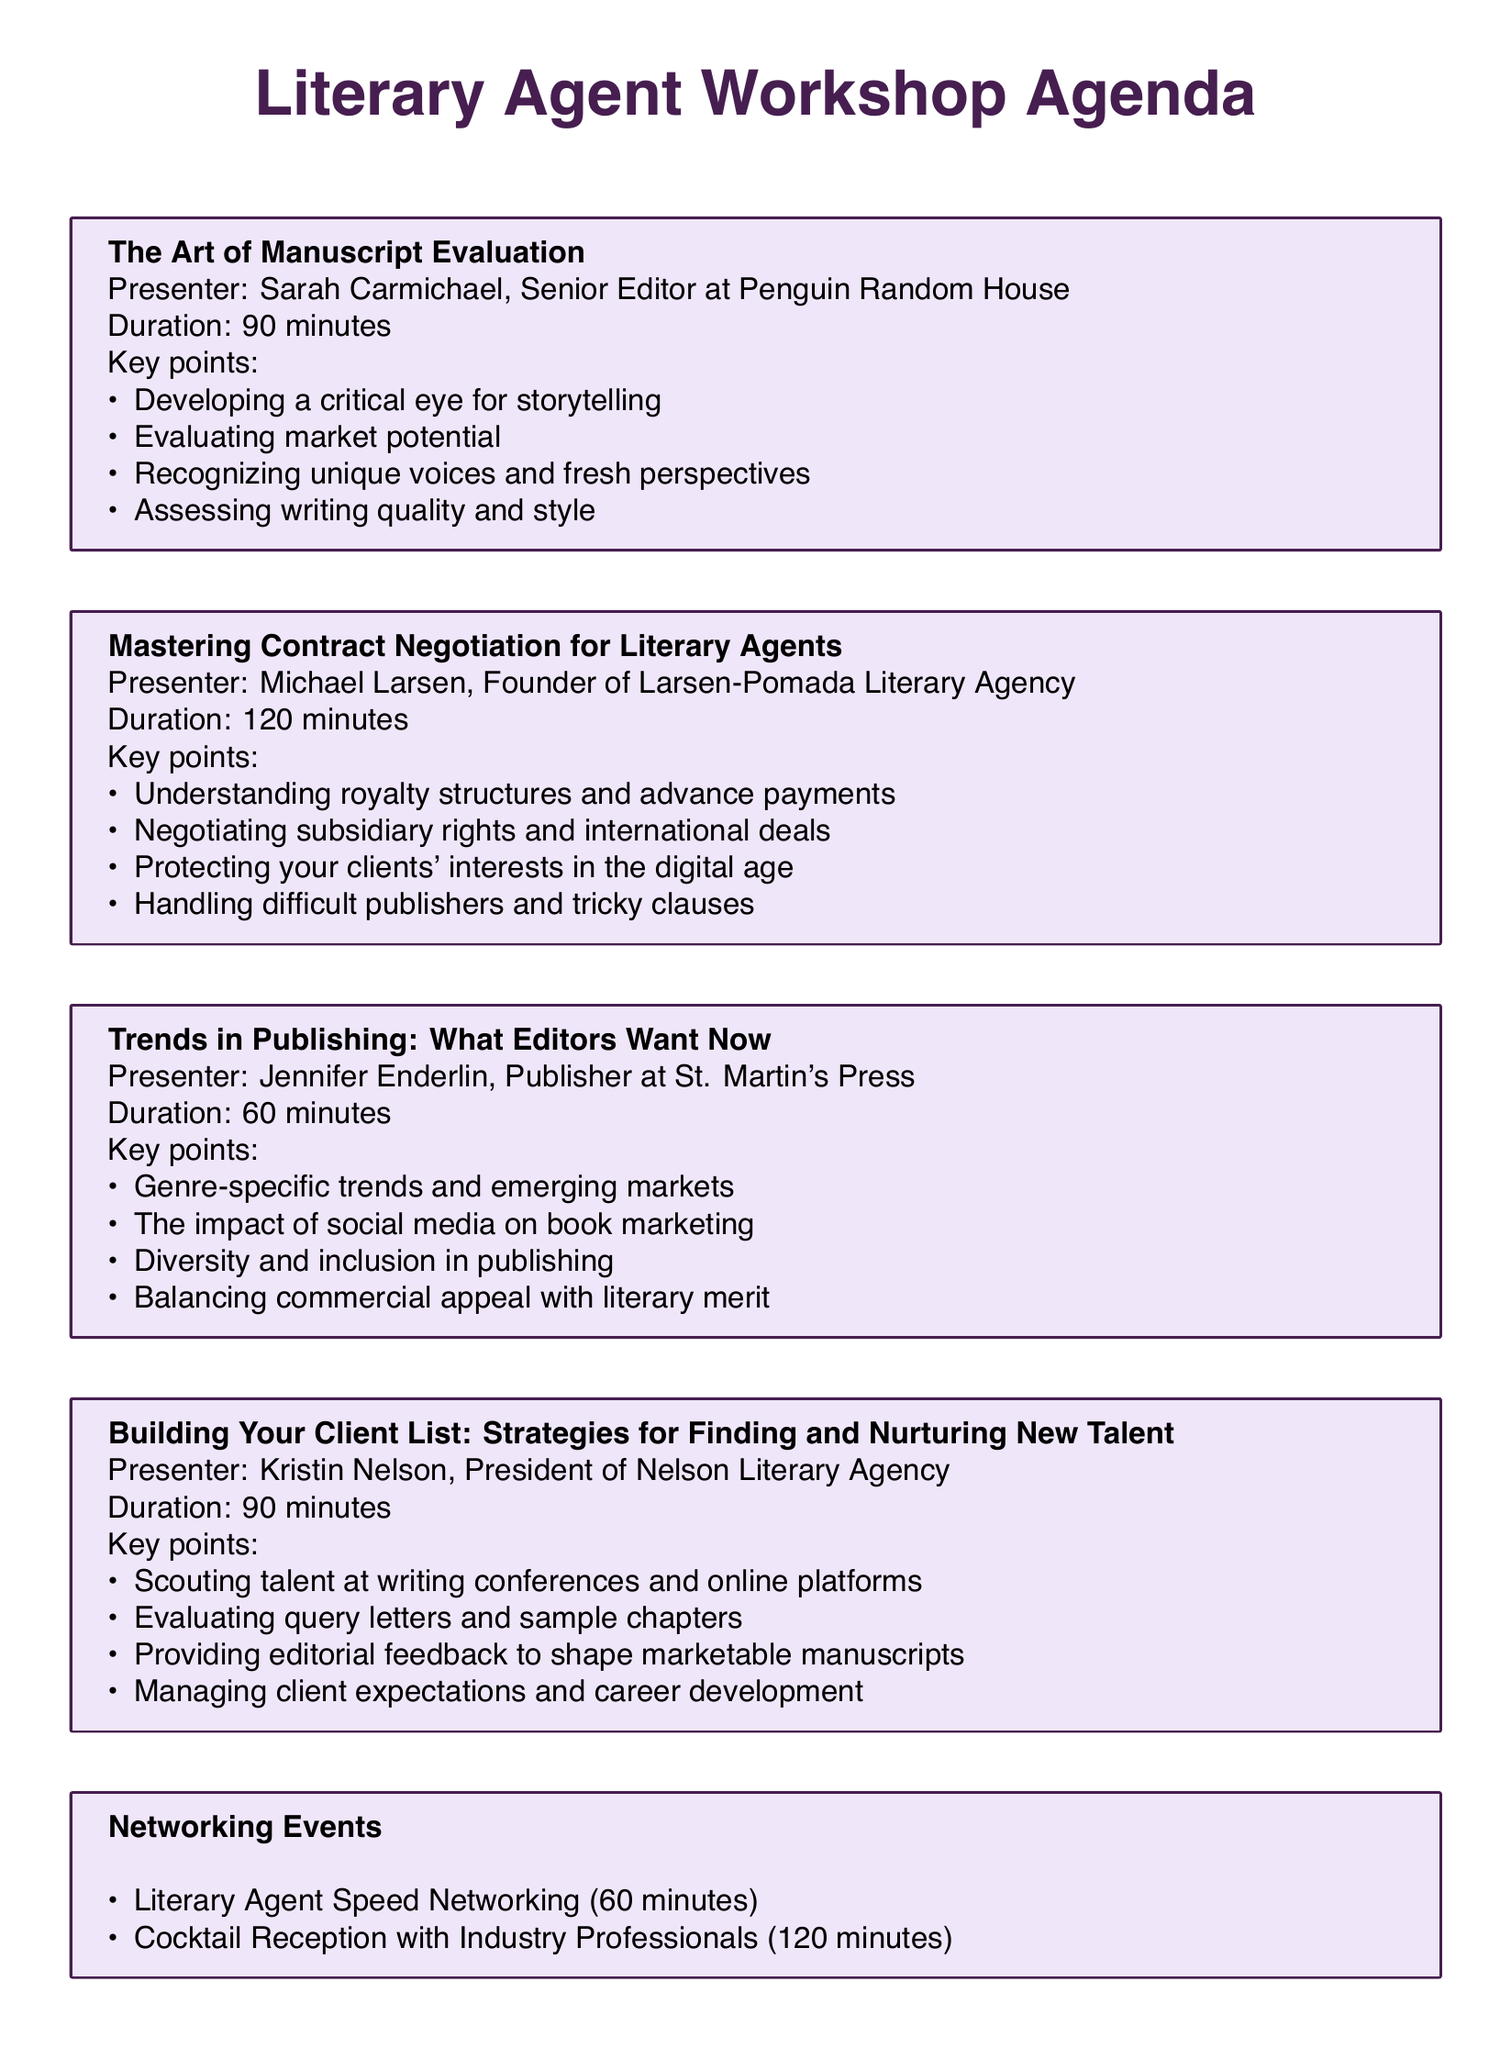What is the duration of "The Art of Manuscript Evaluation"? The duration is specified under the workshop title and is 90 minutes long.
Answer: 90 minutes Who is the presenter for "Mastering Contract Negotiation for Literary Agents"? The presenter's name is indicated in the workshop details, and it is Michael Larsen.
Answer: Michael Larsen What are the key points of "Building Your Client List"? Key points can be found in the workshop description, and they include strategies for finding and nurturing talent.
Answer: Scouting talent at writing conferences and online platforms, Evaluating query letters and sample chapters, Providing editorial feedback to shape marketable manuscripts, Managing client expectations and career development How long is the "Trends in Publishing" workshop? The duration is provided for each workshop, and this one lasts 60 minutes.
Answer: 60 minutes Which networking event lasts the longest? The duration of each networking event is listed, indicating that the Cocktail Reception has the longest duration.
Answer: 120 minutes How many panelists are there in the discussion "The Future of Agenting in the Digital Age"? The number of panelists can be counted directly from the list provided in the panel discussion section.
Answer: 3 What is the main focus of the workshop led by Sarah Carmichael? The focus is outlined in the description following the workshop title and concerns assessing manuscripts.
Answer: Assessing manuscripts What legal topic does Lindsey Bachman’s workshop cover? The description specifies the legal aspects of publishing relevant to literary agents.
Answer: Copyright law and intellectual property rights What is the title of the workshop that includes "digital age"? The workshop title is mentioned at the beginning of the section and includes the term "digital age".
Answer: Mastering Contract Negotiation for Literary Agents 